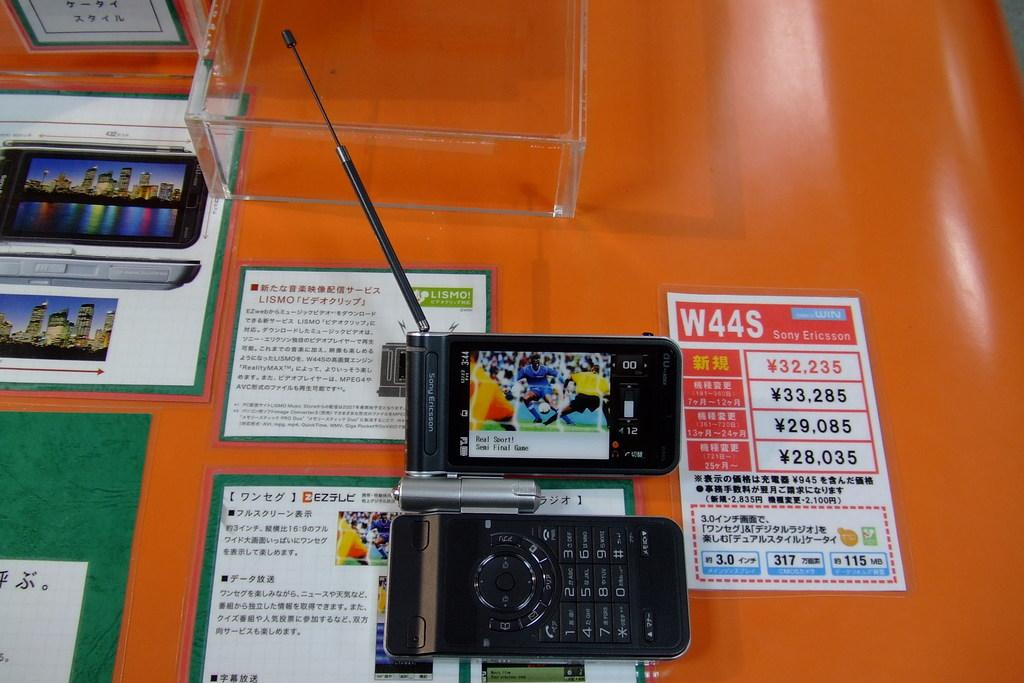<image>
Render a clear and concise summary of the photo. a sony erickson device next to another phone 